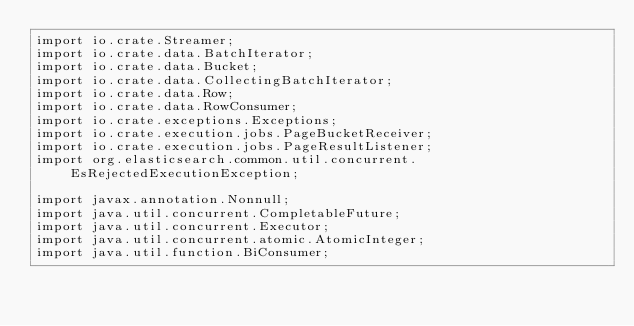Convert code to text. <code><loc_0><loc_0><loc_500><loc_500><_Java_>import io.crate.Streamer;
import io.crate.data.BatchIterator;
import io.crate.data.Bucket;
import io.crate.data.CollectingBatchIterator;
import io.crate.data.Row;
import io.crate.data.RowConsumer;
import io.crate.exceptions.Exceptions;
import io.crate.execution.jobs.PageBucketReceiver;
import io.crate.execution.jobs.PageResultListener;
import org.elasticsearch.common.util.concurrent.EsRejectedExecutionException;

import javax.annotation.Nonnull;
import java.util.concurrent.CompletableFuture;
import java.util.concurrent.Executor;
import java.util.concurrent.atomic.AtomicInteger;
import java.util.function.BiConsumer;</code> 